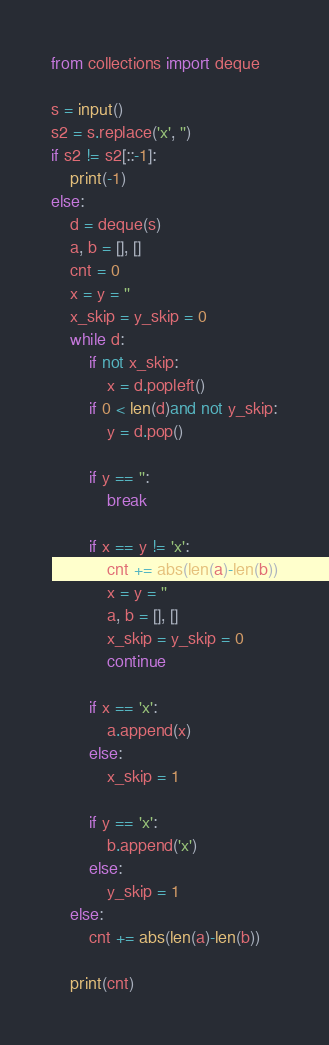Convert code to text. <code><loc_0><loc_0><loc_500><loc_500><_Python_>from collections import deque

s = input()
s2 = s.replace('x', '')
if s2 != s2[::-1]:
    print(-1)
else:
    d = deque(s)
    a, b = [], []
    cnt = 0
    x = y = ''
    x_skip = y_skip = 0
    while d:
        if not x_skip:
            x = d.popleft()
        if 0 < len(d)and not y_skip:
            y = d.pop()

        if y == '':
            break

        if x == y != 'x':
            cnt += abs(len(a)-len(b))
            x = y = ''
            a, b = [], []
            x_skip = y_skip = 0
            continue

        if x == 'x':
            a.append(x)
        else:
            x_skip = 1

        if y == 'x':
            b.append('x')
        else:
            y_skip = 1
    else:
        cnt += abs(len(a)-len(b))

    print(cnt)</code> 